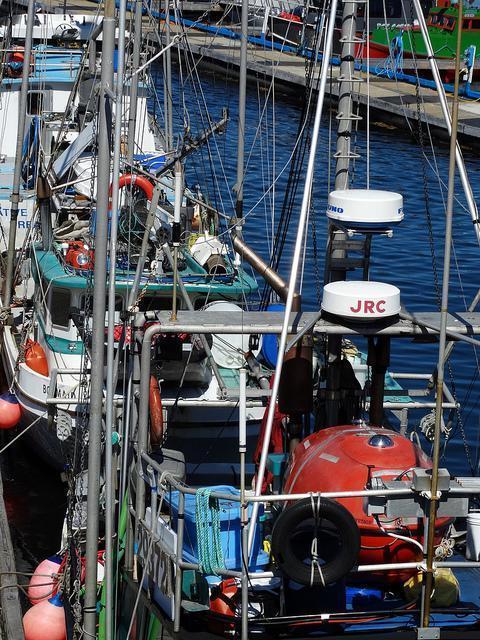What color are the round buoys on the left sides of these boats parked at the marina?
Select the accurate response from the four choices given to answer the question.
Options: Orange, red, white, green. Red. 